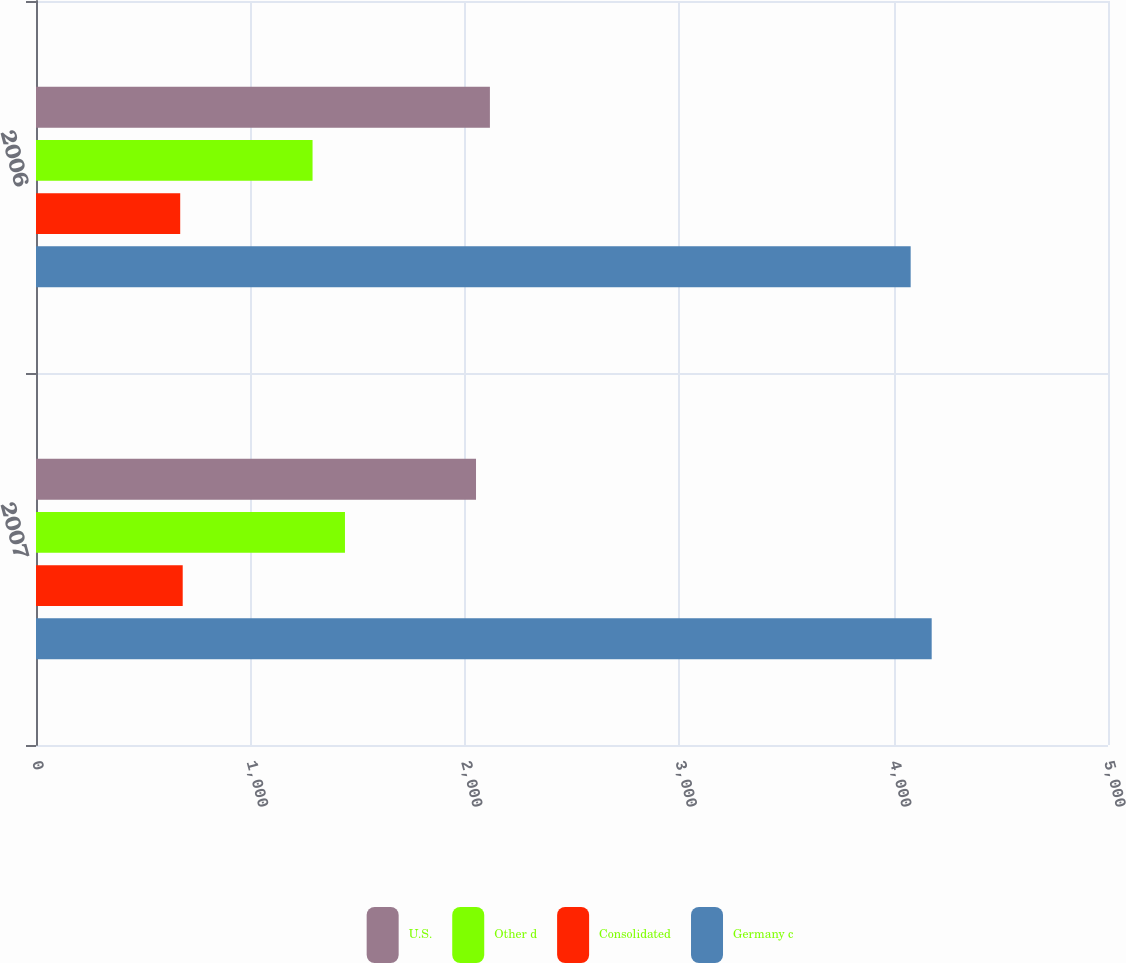Convert chart. <chart><loc_0><loc_0><loc_500><loc_500><stacked_bar_chart><ecel><fcel>2007<fcel>2006<nl><fcel>U.S.<fcel>2052.3<fcel>2117.1<nl><fcel>Other d<fcel>1441.1<fcel>1289.9<nl><fcel>Consolidated<fcel>684.3<fcel>672.6<nl><fcel>Germany c<fcel>4177.7<fcel>4079.6<nl></chart> 